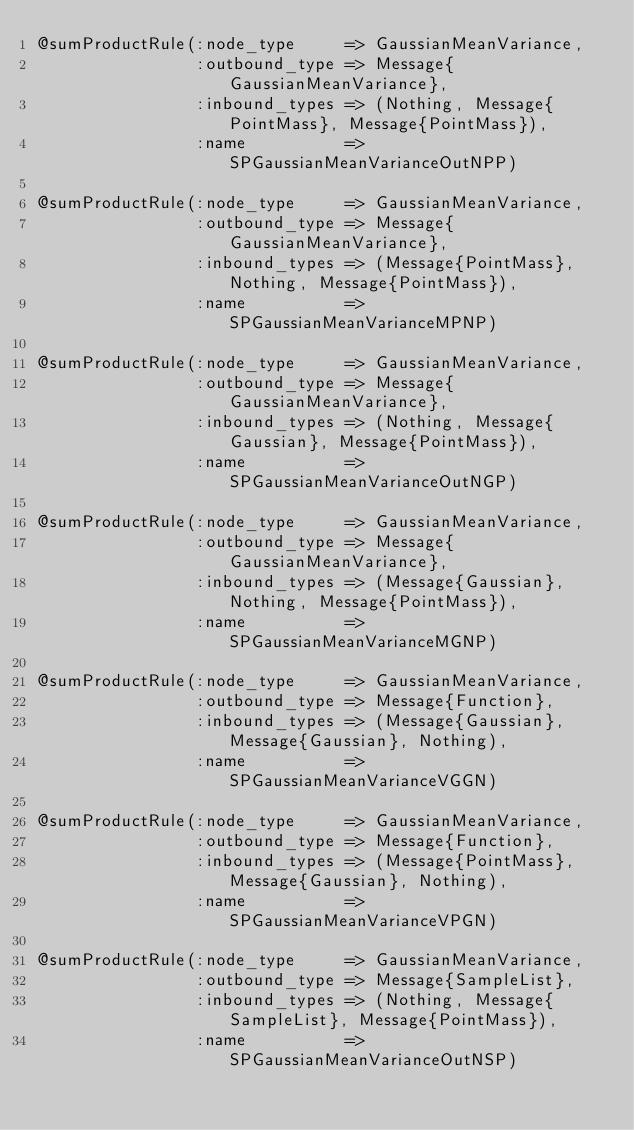<code> <loc_0><loc_0><loc_500><loc_500><_Julia_>@sumProductRule(:node_type     => GaussianMeanVariance,
                :outbound_type => Message{GaussianMeanVariance},
                :inbound_types => (Nothing, Message{PointMass}, Message{PointMass}),
                :name          => SPGaussianMeanVarianceOutNPP)

@sumProductRule(:node_type     => GaussianMeanVariance,
                :outbound_type => Message{GaussianMeanVariance},
                :inbound_types => (Message{PointMass}, Nothing, Message{PointMass}),
                :name          => SPGaussianMeanVarianceMPNP)

@sumProductRule(:node_type     => GaussianMeanVariance,
                :outbound_type => Message{GaussianMeanVariance},
                :inbound_types => (Nothing, Message{Gaussian}, Message{PointMass}),
                :name          => SPGaussianMeanVarianceOutNGP)

@sumProductRule(:node_type     => GaussianMeanVariance,
                :outbound_type => Message{GaussianMeanVariance},
                :inbound_types => (Message{Gaussian}, Nothing, Message{PointMass}),
                :name          => SPGaussianMeanVarianceMGNP)

@sumProductRule(:node_type     => GaussianMeanVariance,
                :outbound_type => Message{Function},
                :inbound_types => (Message{Gaussian}, Message{Gaussian}, Nothing),
                :name          => SPGaussianMeanVarianceVGGN)

@sumProductRule(:node_type     => GaussianMeanVariance,
                :outbound_type => Message{Function},
                :inbound_types => (Message{PointMass}, Message{Gaussian}, Nothing),
                :name          => SPGaussianMeanVarianceVPGN)

@sumProductRule(:node_type     => GaussianMeanVariance,
                :outbound_type => Message{SampleList},
                :inbound_types => (Nothing, Message{SampleList}, Message{PointMass}),
                :name          => SPGaussianMeanVarianceOutNSP)
</code> 